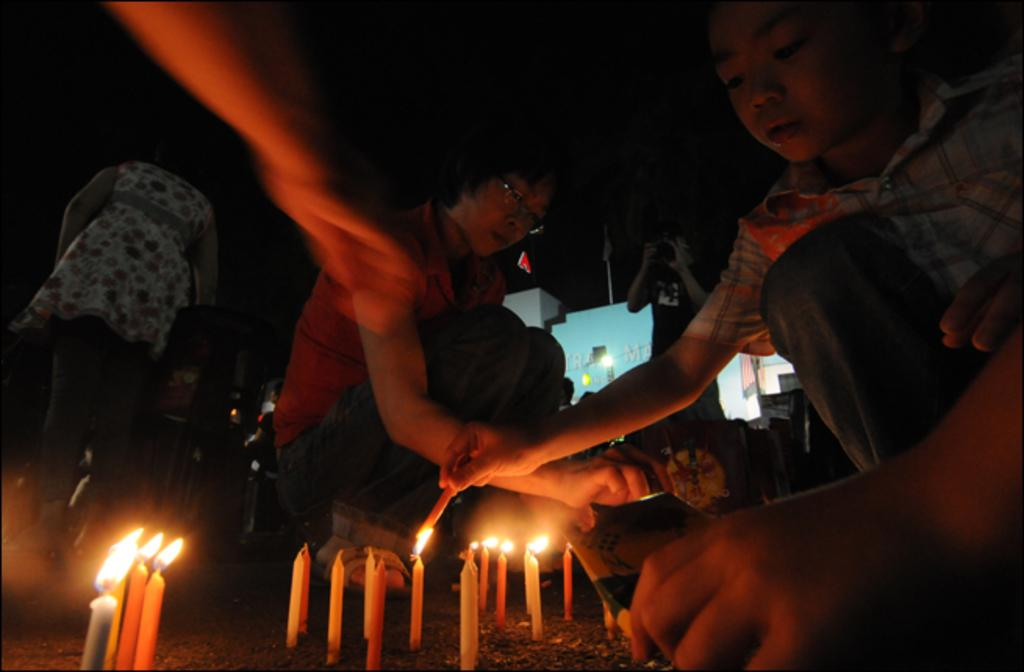What objects are present at the bottom of the image? There are many candles at the bottom of the image. What are the people in the image doing with the candles? People are lighting the candles in the image. What type of lead is being used to light the candles in the image? There is no mention of lead being used to light the candles in the image. The people are likely using matches or a lighter. 